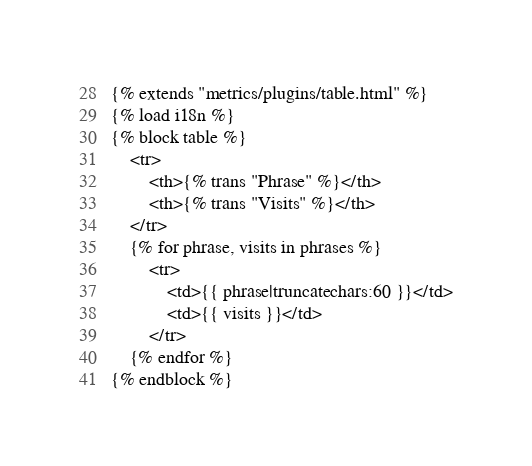<code> <loc_0><loc_0><loc_500><loc_500><_HTML_>{% extends "metrics/plugins/table.html" %}
{% load i18n %}
{% block table %}
    <tr>
        <th>{% trans "Phrase" %}</th>
        <th>{% trans "Visits" %}</th>
    </tr>
    {% for phrase, visits in phrases %}
        <tr>
            <td>{{ phrase|truncatechars:60 }}</td>
            <td>{{ visits }}</td>
        </tr>
    {% endfor %}
{% endblock %}
</code> 